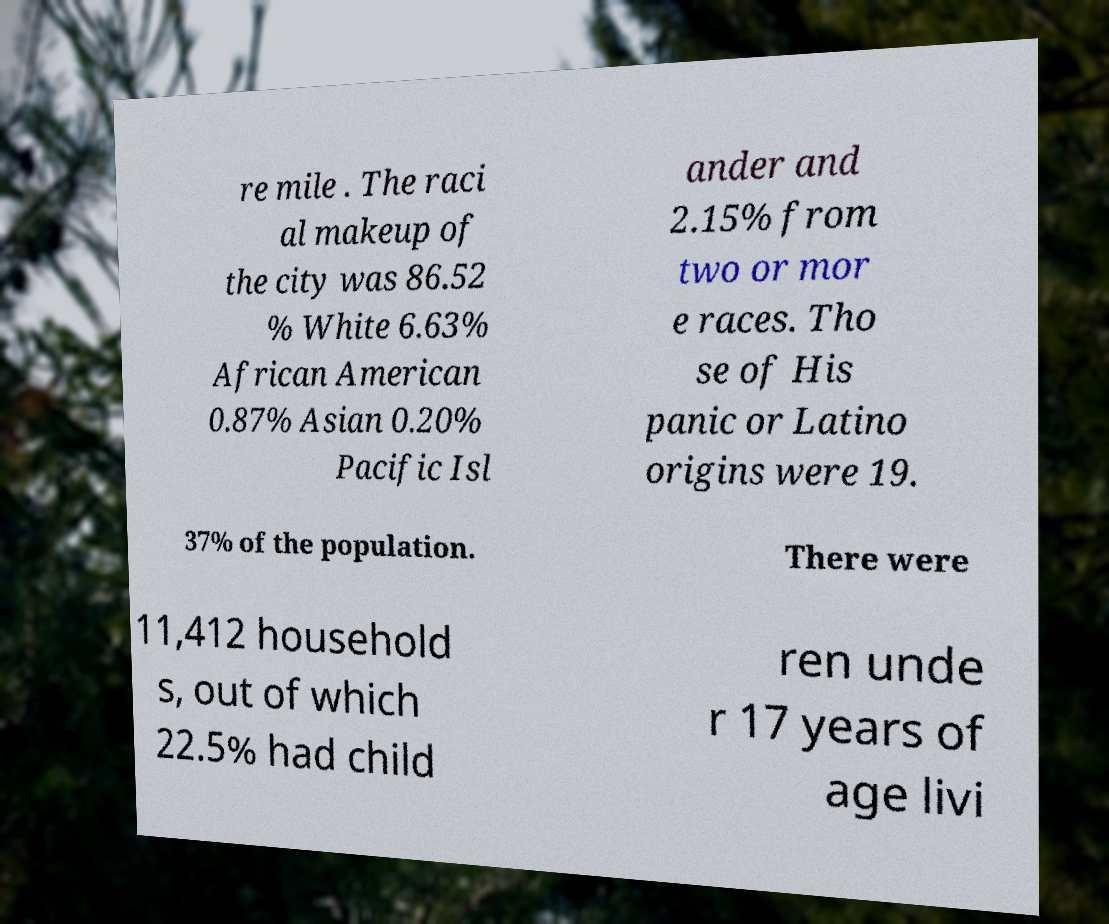What messages or text are displayed in this image? I need them in a readable, typed format. re mile . The raci al makeup of the city was 86.52 % White 6.63% African American 0.87% Asian 0.20% Pacific Isl ander and 2.15% from two or mor e races. Tho se of His panic or Latino origins were 19. 37% of the population. There were 11,412 household s, out of which 22.5% had child ren unde r 17 years of age livi 